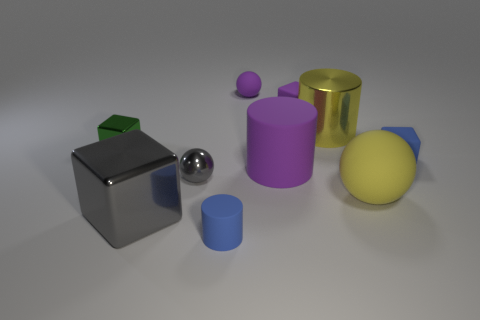Subtract all balls. How many objects are left? 7 Add 7 large yellow balls. How many large yellow balls are left? 8 Add 1 tiny gray cylinders. How many tiny gray cylinders exist? 1 Subtract 0 red cubes. How many objects are left? 10 Subtract all blue matte blocks. Subtract all yellow cylinders. How many objects are left? 8 